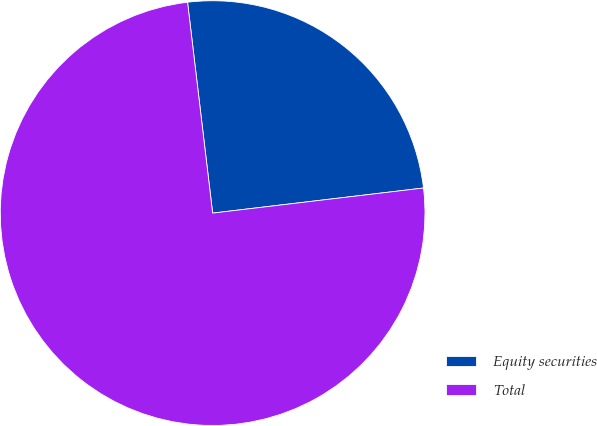<chart> <loc_0><loc_0><loc_500><loc_500><pie_chart><fcel>Equity securities<fcel>Total<nl><fcel>25.0%<fcel>75.0%<nl></chart> 